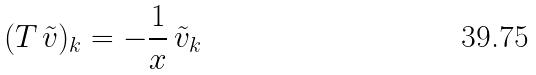Convert formula to latex. <formula><loc_0><loc_0><loc_500><loc_500>( T \, \tilde { v } ) _ { k } = - \frac { 1 } { x } \, \tilde { v } _ { k }</formula> 